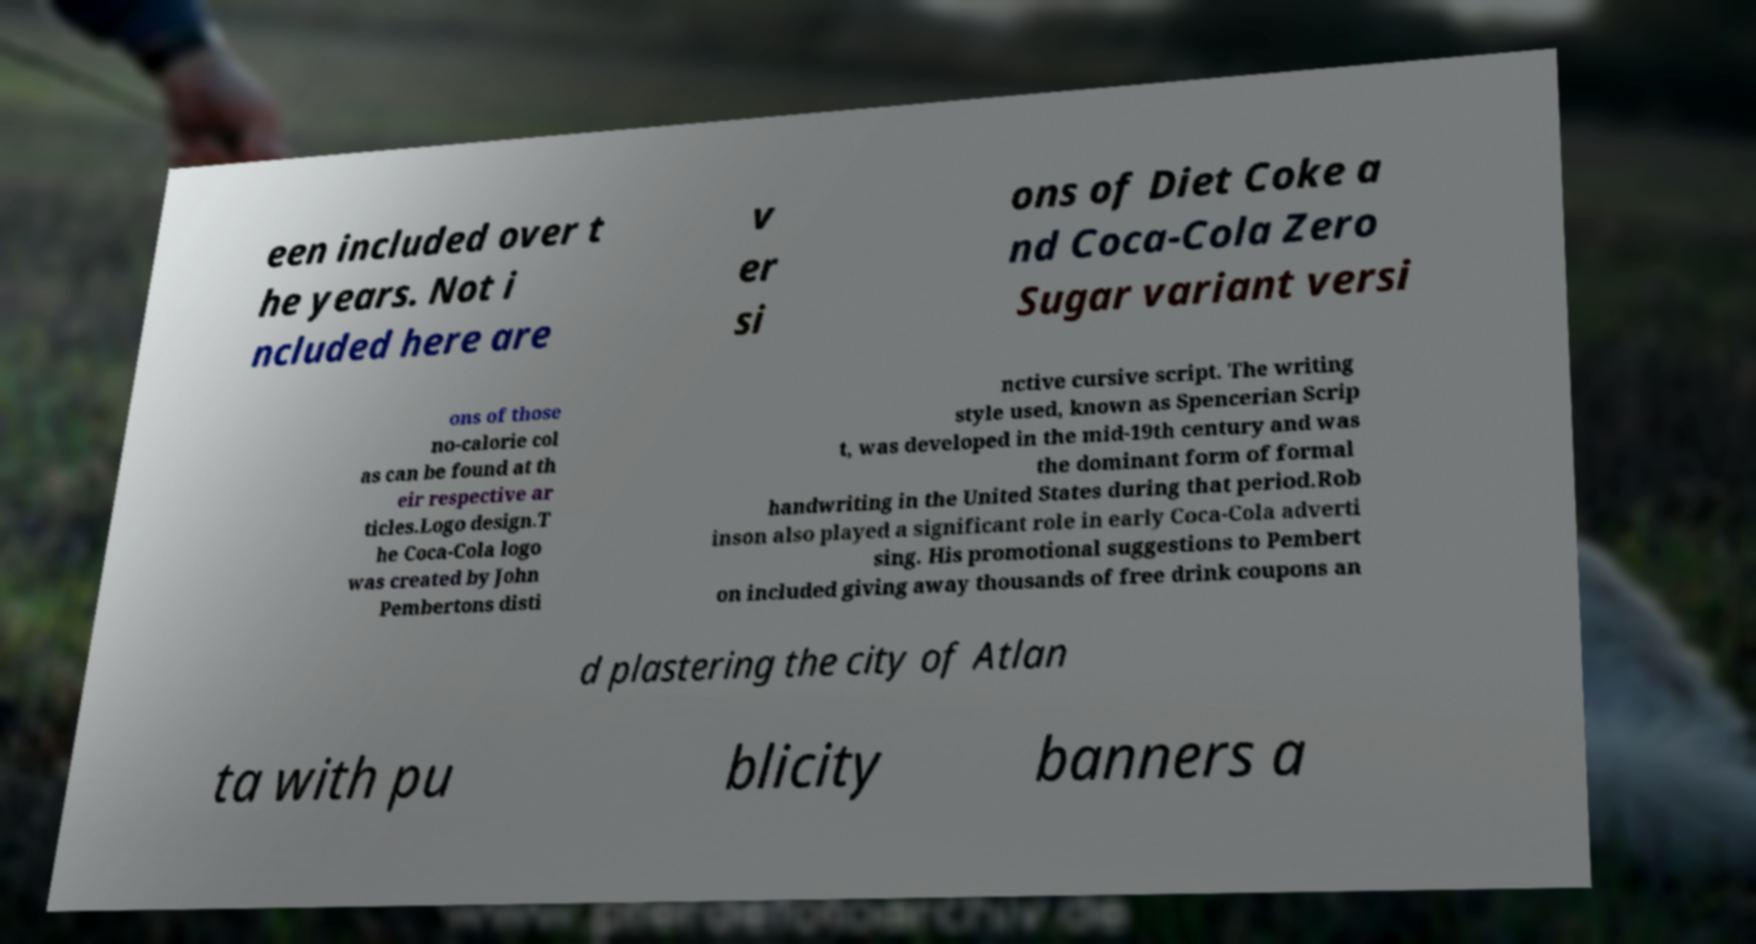For documentation purposes, I need the text within this image transcribed. Could you provide that? een included over t he years. Not i ncluded here are v er si ons of Diet Coke a nd Coca-Cola Zero Sugar variant versi ons of those no-calorie col as can be found at th eir respective ar ticles.Logo design.T he Coca-Cola logo was created by John Pembertons disti nctive cursive script. The writing style used, known as Spencerian Scrip t, was developed in the mid-19th century and was the dominant form of formal handwriting in the United States during that period.Rob inson also played a significant role in early Coca-Cola adverti sing. His promotional suggestions to Pembert on included giving away thousands of free drink coupons an d plastering the city of Atlan ta with pu blicity banners a 